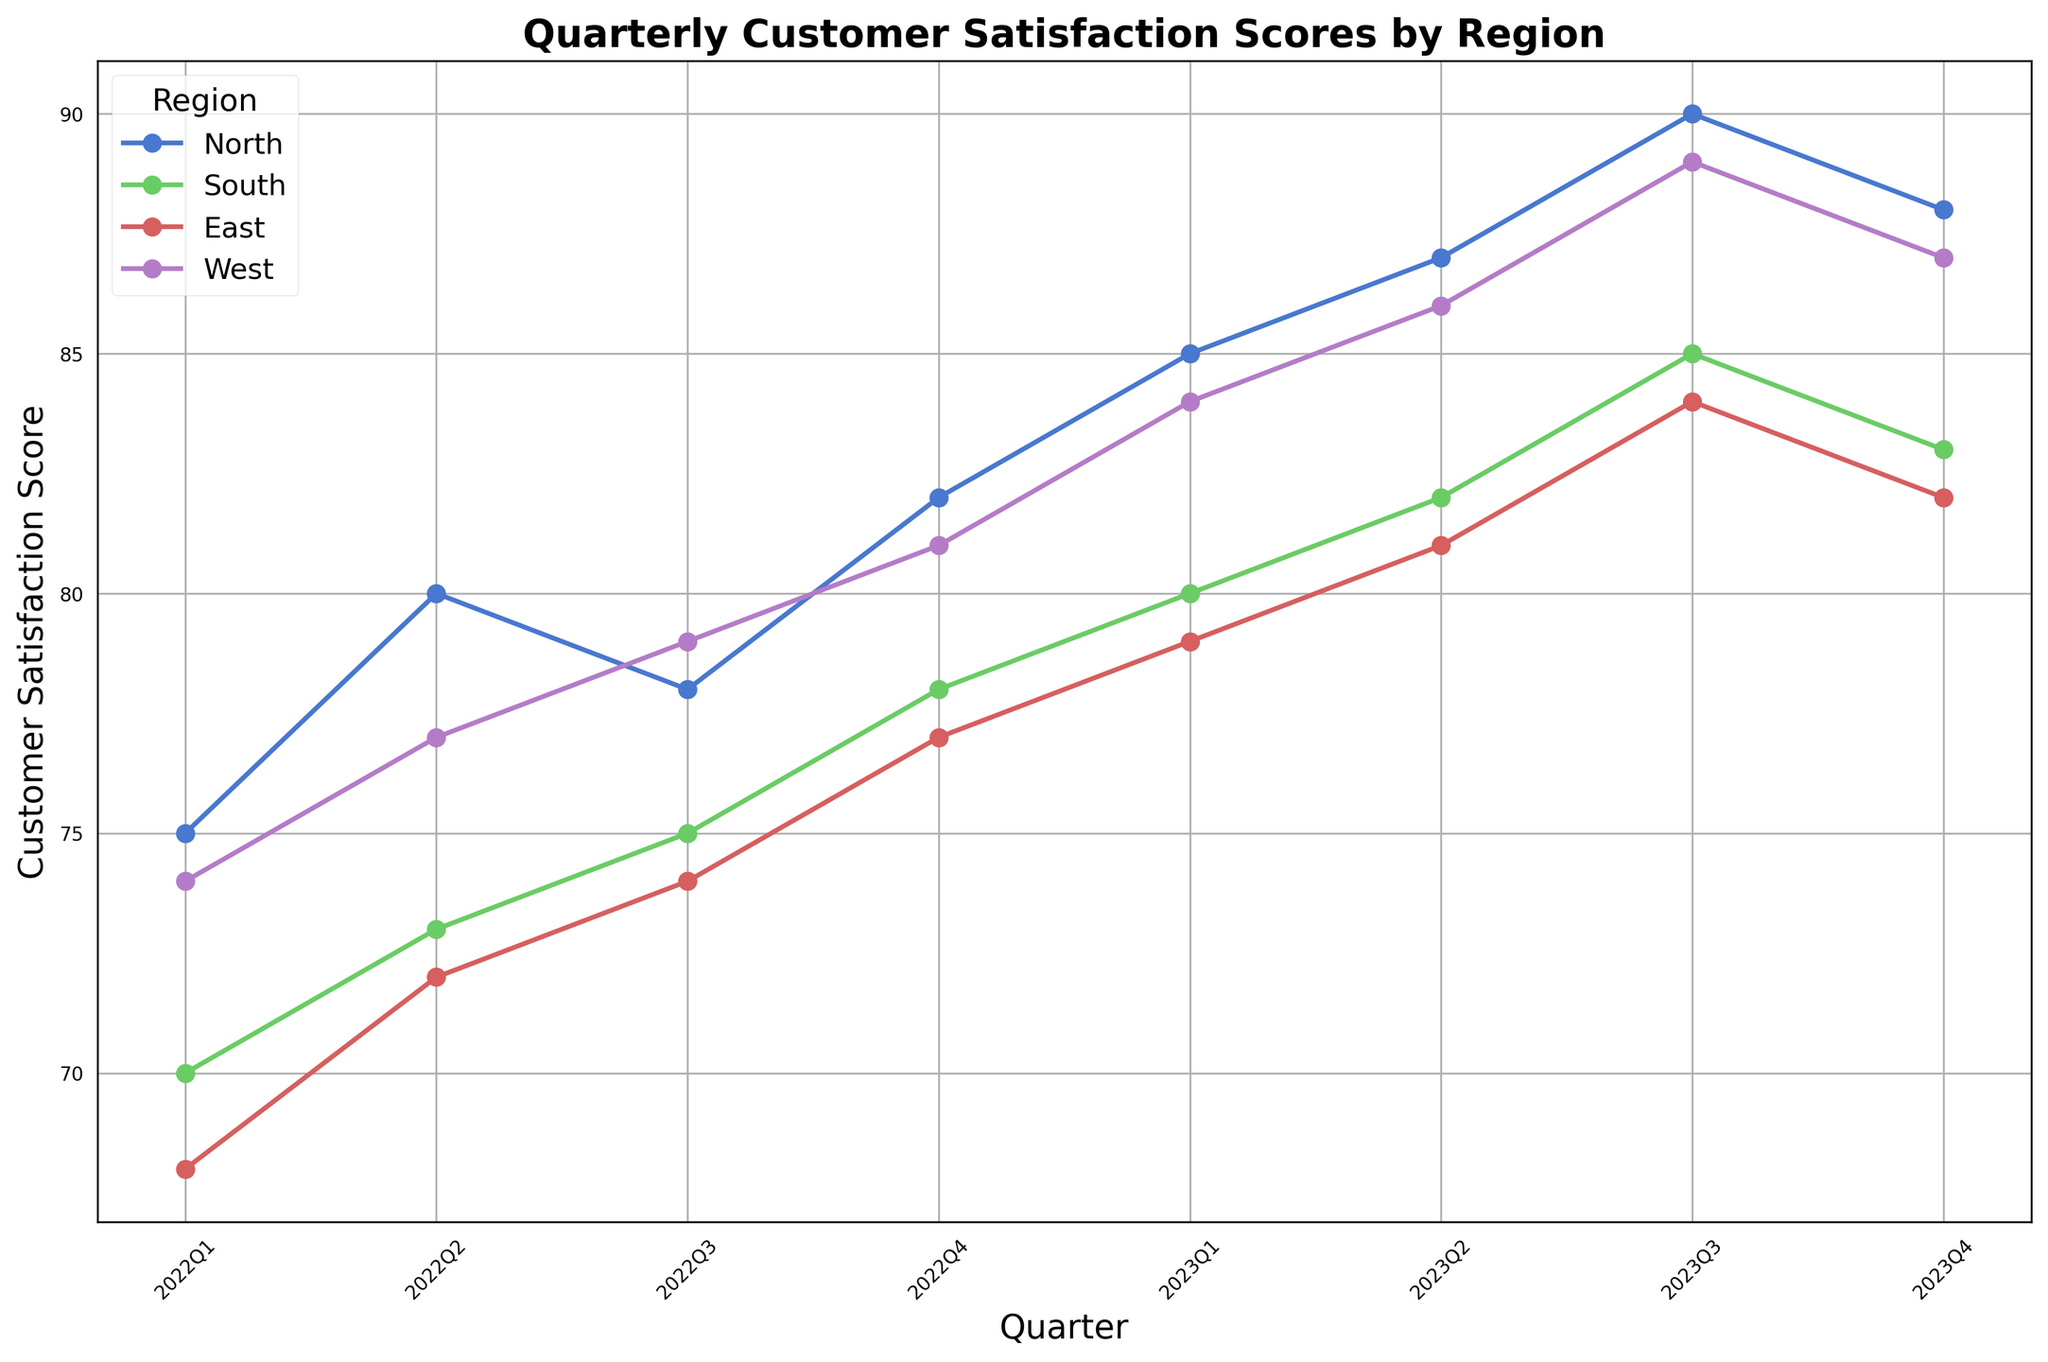What region had the highest customer satisfaction score in the last quarter of 2023? By looking at the lines and their positions in the last quarter, inspect the labels of the highest line in that quarter.
Answer: North Which region showed the most significant improvement from 2022Q1 to 2023Q4? Calculate the difference in customer satisfaction score between 2022Q1 and 2023Q4 for each region. North: 88-75 = 13, South: 83-70 = 13, East: 82-68 = 14, West: 87-74 = 13. The East region shows the highest improvement of 14 points.
Answer: East During which quarter did the South region exceed a customer satisfaction score of 80 for the first time? By inspecting the line corresponding to the South region, identify the quarter when the score first exceeded 80.
Answer: 2023Q1 Comparing 2022Q4 and 2023Q2, which region had a higher customer satisfaction score in both quarters consistently? Review the scores of all regions for both quarters and find the one that is consistently higher. For 2022Q4/2023Q2, North: 82/87, South: 78/82, East: 77/81, West: 81/86. North and West are consistently higher.
Answer: North and West Which regions showed a decrease in customer satisfaction score from 2023Q3 to 2023Q4? Identify the segments where the line shows a downward slope from 2023Q3 to 2023Q4.
Answer: North, South, East, West What is the average customer satisfaction score of all regions in 2023Q4? Sum the 2023Q4 scores of all regions and divide by the number of regions. (88+83+82+87)/4 = 85
Answer: 85 In which quarter did the East region see the highest satisfaction score? Inspect the East line to find the quarter where its score reaches the peak.
Answer: 2023Q3 Which region had the lowest satisfaction score in 2022Q1? Inspect the starting points of all lines to find the lowest one in 2022Q1.
Answer: East 